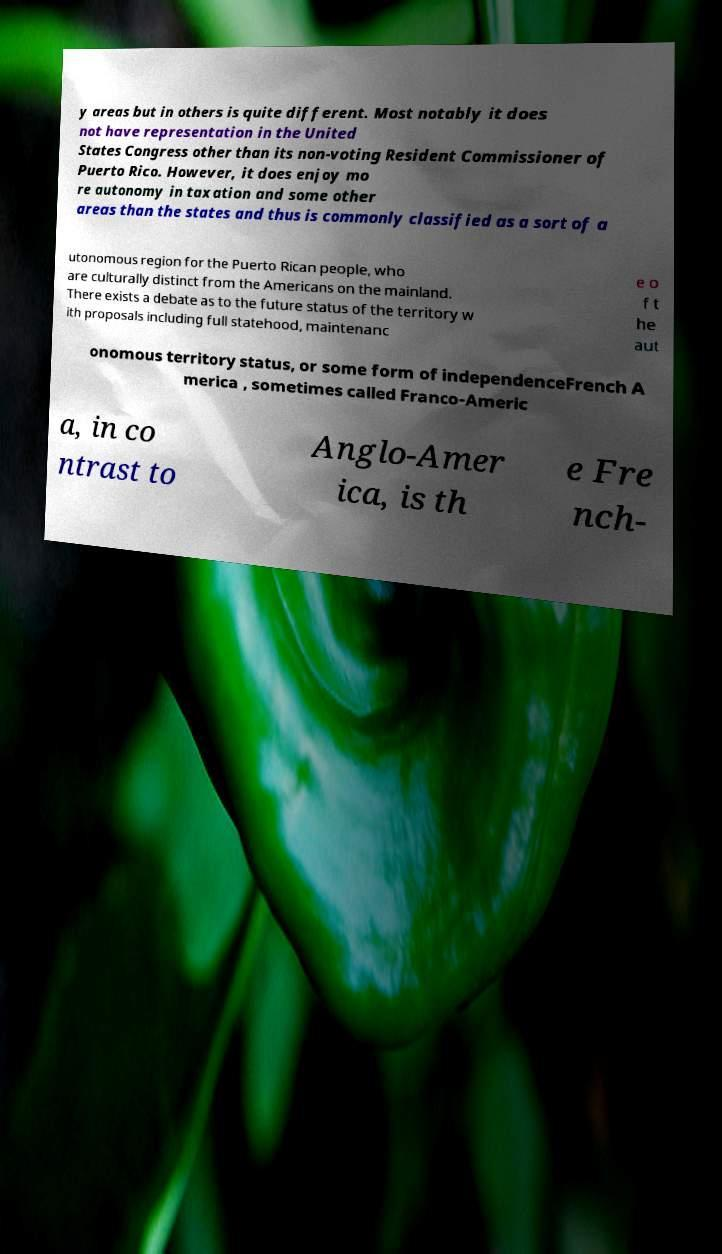Please read and relay the text visible in this image. What does it say? y areas but in others is quite different. Most notably it does not have representation in the United States Congress other than its non-voting Resident Commissioner of Puerto Rico. However, it does enjoy mo re autonomy in taxation and some other areas than the states and thus is commonly classified as a sort of a utonomous region for the Puerto Rican people, who are culturally distinct from the Americans on the mainland. There exists a debate as to the future status of the territory w ith proposals including full statehood, maintenanc e o f t he aut onomous territory status, or some form of independenceFrench A merica , sometimes called Franco-Americ a, in co ntrast to Anglo-Amer ica, is th e Fre nch- 